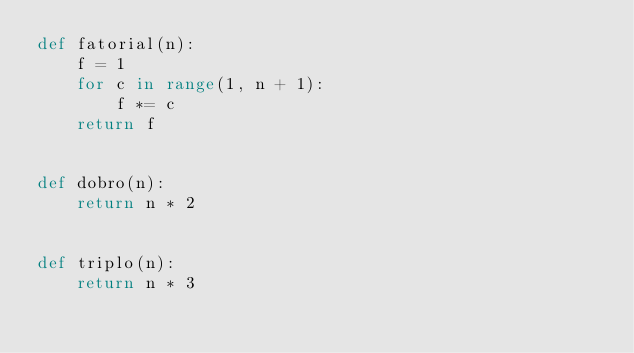<code> <loc_0><loc_0><loc_500><loc_500><_Python_>def fatorial(n):
    f = 1
    for c in range(1, n + 1):
        f *= c
    return f


def dobro(n):
    return n * 2


def triplo(n):
    return n * 3</code> 